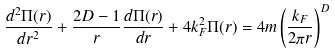<formula> <loc_0><loc_0><loc_500><loc_500>\frac { d ^ { 2 } \Pi ( r ) } { d r ^ { 2 } } + \frac { 2 D - 1 } { r } \frac { d \Pi ( r ) } { d r } + 4 k _ { F } ^ { 2 } \Pi ( r ) = 4 m \left ( \frac { k _ { F } } { 2 \pi r } \right ) ^ { D }</formula> 